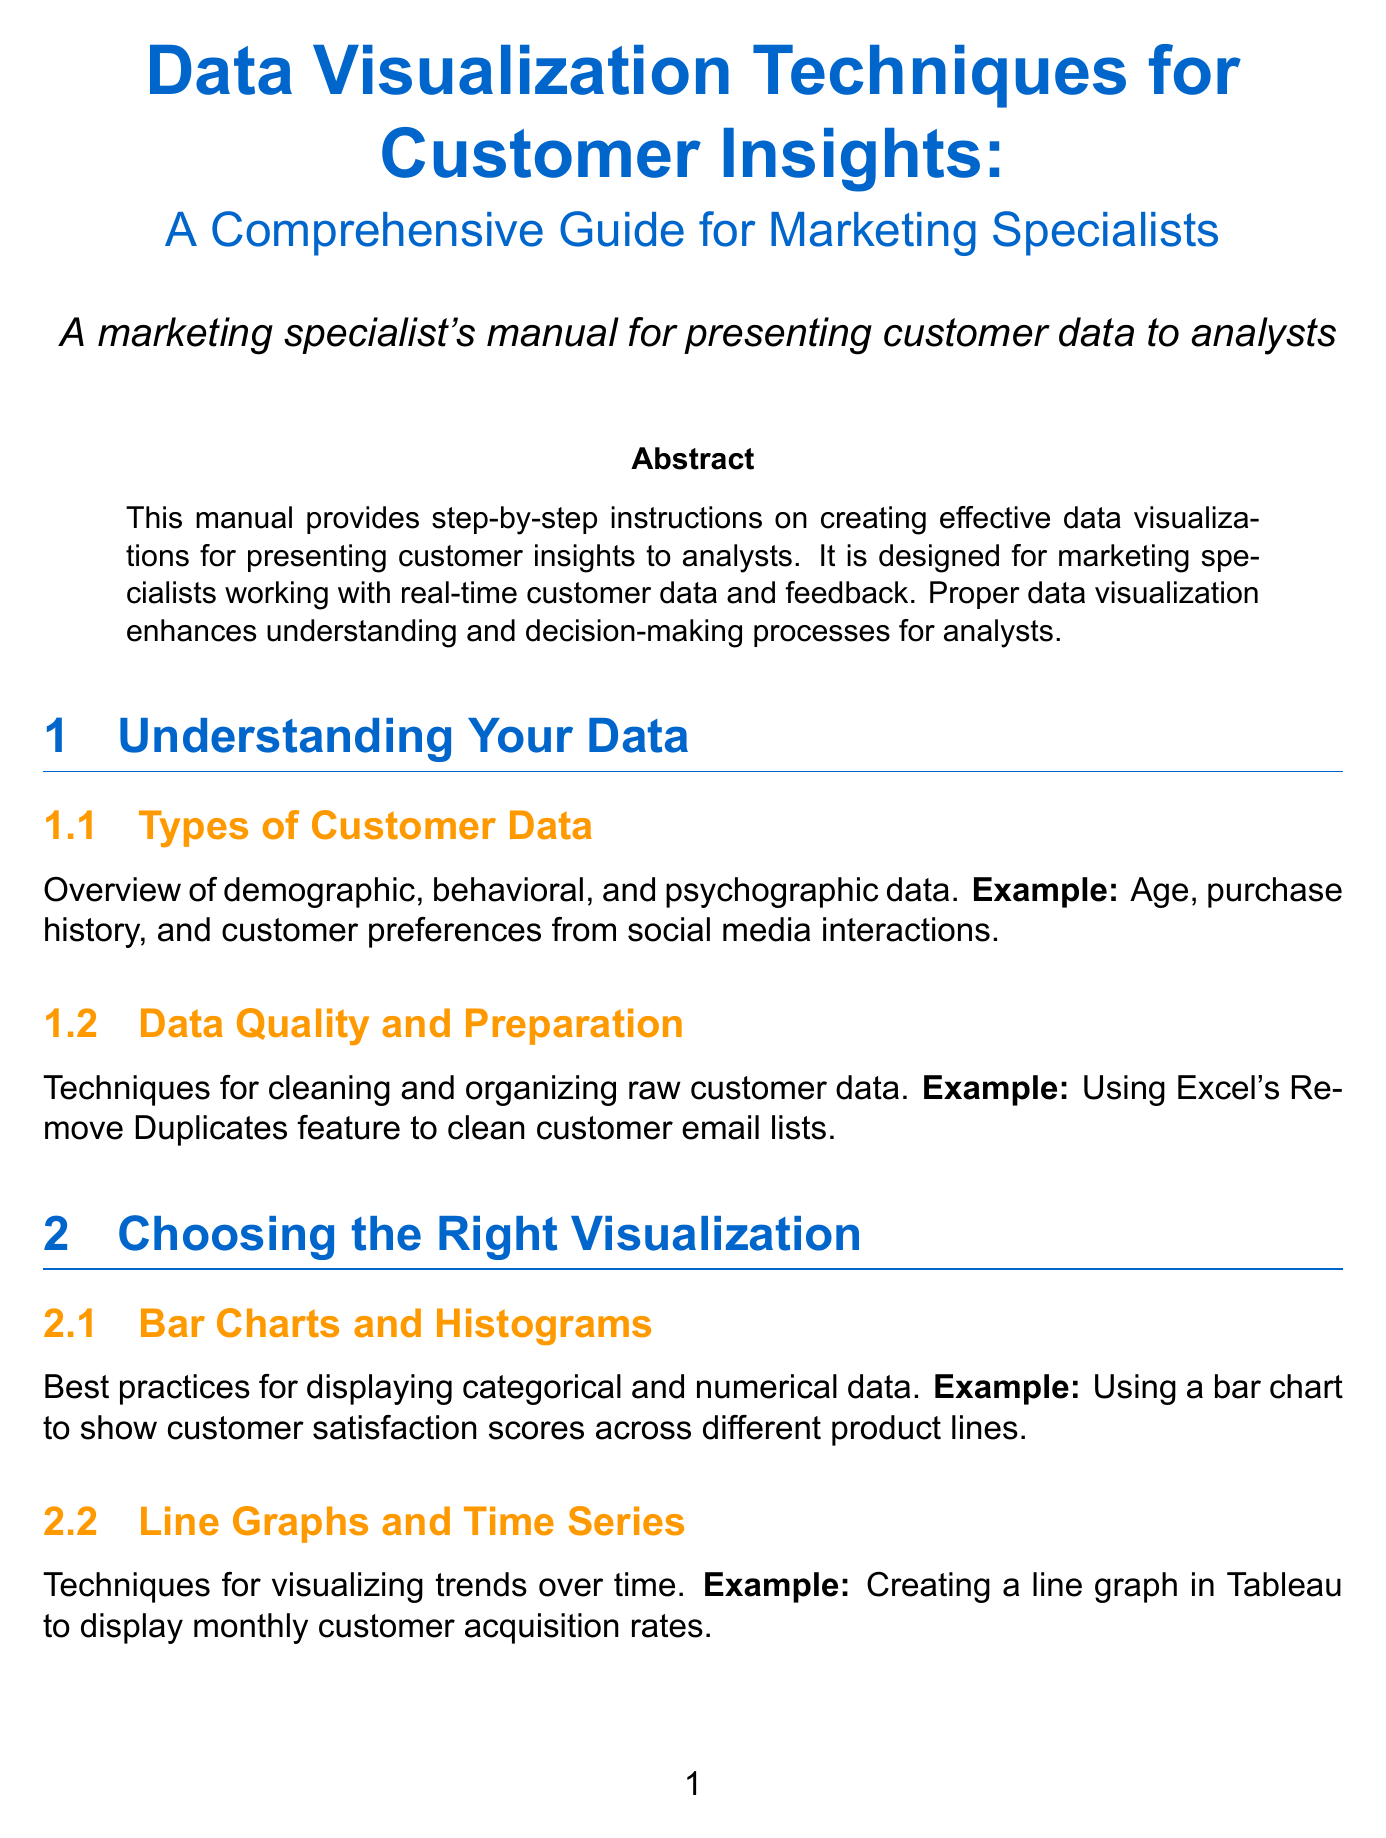What is the manual's title? The title of the manual is provided at the beginning of the document.
Answer: Data Visualization Techniques for Customer Insights: A Comprehensive Guide for Marketing Specialists Who is the target audience of the manual? The target audience is explicitly mentioned in the introduction section of the document.
Answer: Marketing specialists working with real-time customer data and feedback What software is used to create interactive dashboards? The specific tools and software mentioned in the document highlight various data visualization options including their use cases.
Answer: Tableau What type of visualization is recommended for part-to-whole comparisons? The document describes different visualization types and their appropriate uses, including one for part-to-whole comparisons.
Answer: Pie Charts and Treemaps Which chapter discusses interactive dashboards? The structure of the manual includes multiple chapters, and the chapter names correspond directly to their content.
Answer: Interactive Dashboards What is one best practice mentioned for visualizations? The document lists multiple best practices that should be followed when creating visualizations to enhance clarity and understanding.
Answer: Provide context and explanations for complex visualizations What example is given for using heat maps? Examples are provided in each section, illustrating practical applications of the techniques discussed.
Answer: Creating a heat map in Seaborn to visualize customer engagement across different times and channels What does “storytelling with data” refer to in the manual? This phrase corresponds to a specific section discussing how to effectively present data insights.
Answer: Techniques for crafting compelling narratives around customer insights What is emphasized as crucial for presenting customer insights to analysts? The conclusion summarizes the significance of a specific practice mentioned throughout the manual.
Answer: Effective data visualization 